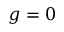<formula> <loc_0><loc_0><loc_500><loc_500>g = 0</formula> 